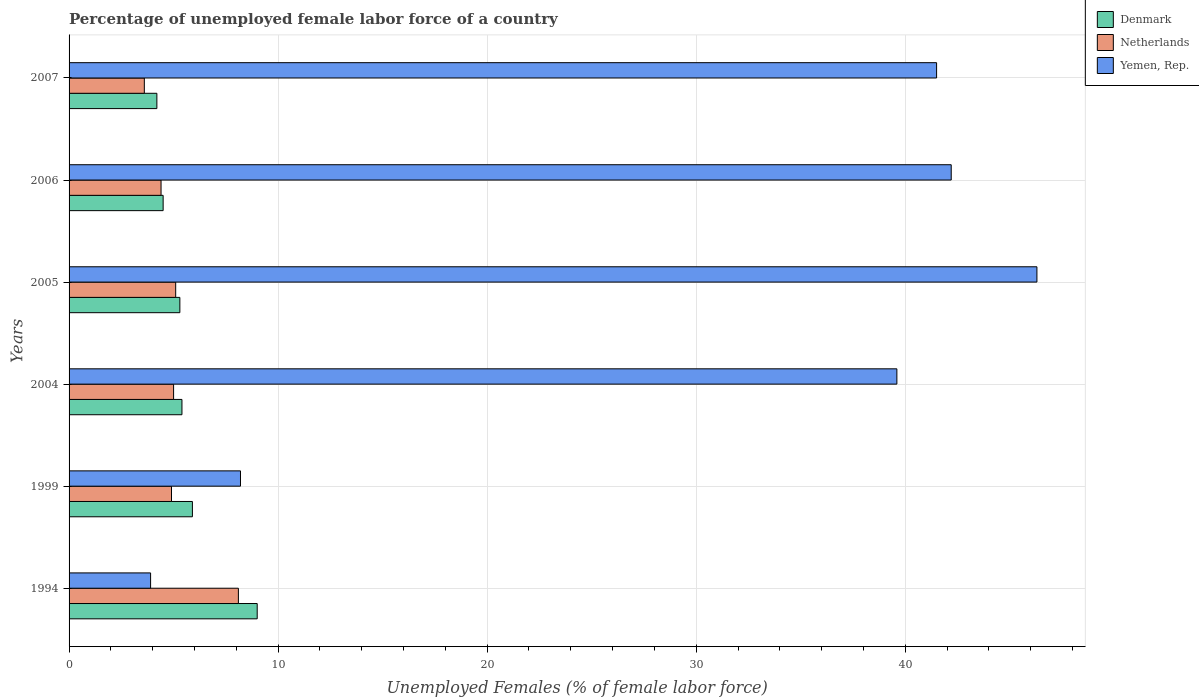Are the number of bars per tick equal to the number of legend labels?
Provide a short and direct response. Yes. Are the number of bars on each tick of the Y-axis equal?
Your answer should be very brief. Yes. How many bars are there on the 1st tick from the top?
Give a very brief answer. 3. What is the label of the 1st group of bars from the top?
Offer a very short reply. 2007. In how many cases, is the number of bars for a given year not equal to the number of legend labels?
Make the answer very short. 0. What is the percentage of unemployed female labor force in Denmark in 2004?
Provide a short and direct response. 5.4. Across all years, what is the maximum percentage of unemployed female labor force in Denmark?
Ensure brevity in your answer.  9. Across all years, what is the minimum percentage of unemployed female labor force in Yemen, Rep.?
Your answer should be very brief. 3.9. What is the total percentage of unemployed female labor force in Netherlands in the graph?
Offer a very short reply. 31.1. What is the difference between the percentage of unemployed female labor force in Denmark in 2005 and that in 2007?
Your answer should be compact. 1.1. What is the difference between the percentage of unemployed female labor force in Yemen, Rep. in 2006 and the percentage of unemployed female labor force in Netherlands in 2007?
Provide a short and direct response. 38.6. What is the average percentage of unemployed female labor force in Yemen, Rep. per year?
Keep it short and to the point. 30.28. In the year 2004, what is the difference between the percentage of unemployed female labor force in Netherlands and percentage of unemployed female labor force in Yemen, Rep.?
Make the answer very short. -34.6. In how many years, is the percentage of unemployed female labor force in Denmark greater than 10 %?
Give a very brief answer. 0. What is the ratio of the percentage of unemployed female labor force in Netherlands in 2004 to that in 2006?
Your answer should be compact. 1.14. Is the percentage of unemployed female labor force in Yemen, Rep. in 1994 less than that in 2004?
Your answer should be compact. Yes. Is the difference between the percentage of unemployed female labor force in Netherlands in 2004 and 2007 greater than the difference between the percentage of unemployed female labor force in Yemen, Rep. in 2004 and 2007?
Your response must be concise. Yes. What is the difference between the highest and the second highest percentage of unemployed female labor force in Netherlands?
Your response must be concise. 3. What is the difference between the highest and the lowest percentage of unemployed female labor force in Denmark?
Offer a terse response. 4.8. Is the sum of the percentage of unemployed female labor force in Yemen, Rep. in 1999 and 2005 greater than the maximum percentage of unemployed female labor force in Denmark across all years?
Ensure brevity in your answer.  Yes. What does the 2nd bar from the top in 2005 represents?
Make the answer very short. Netherlands. What does the 1st bar from the bottom in 2005 represents?
Offer a terse response. Denmark. Is it the case that in every year, the sum of the percentage of unemployed female labor force in Yemen, Rep. and percentage of unemployed female labor force in Netherlands is greater than the percentage of unemployed female labor force in Denmark?
Make the answer very short. Yes. How many bars are there?
Your answer should be compact. 18. How many years are there in the graph?
Ensure brevity in your answer.  6. Does the graph contain any zero values?
Keep it short and to the point. No. How are the legend labels stacked?
Provide a short and direct response. Vertical. What is the title of the graph?
Provide a succinct answer. Percentage of unemployed female labor force of a country. Does "Hong Kong" appear as one of the legend labels in the graph?
Offer a very short reply. No. What is the label or title of the X-axis?
Make the answer very short. Unemployed Females (% of female labor force). What is the Unemployed Females (% of female labor force) of Denmark in 1994?
Your answer should be very brief. 9. What is the Unemployed Females (% of female labor force) in Netherlands in 1994?
Offer a terse response. 8.1. What is the Unemployed Females (% of female labor force) of Yemen, Rep. in 1994?
Ensure brevity in your answer.  3.9. What is the Unemployed Females (% of female labor force) in Denmark in 1999?
Ensure brevity in your answer.  5.9. What is the Unemployed Females (% of female labor force) of Netherlands in 1999?
Your answer should be very brief. 4.9. What is the Unemployed Females (% of female labor force) in Yemen, Rep. in 1999?
Keep it short and to the point. 8.2. What is the Unemployed Females (% of female labor force) of Denmark in 2004?
Provide a short and direct response. 5.4. What is the Unemployed Females (% of female labor force) of Netherlands in 2004?
Keep it short and to the point. 5. What is the Unemployed Females (% of female labor force) of Yemen, Rep. in 2004?
Make the answer very short. 39.6. What is the Unemployed Females (% of female labor force) of Denmark in 2005?
Your answer should be very brief. 5.3. What is the Unemployed Females (% of female labor force) in Netherlands in 2005?
Offer a very short reply. 5.1. What is the Unemployed Females (% of female labor force) of Yemen, Rep. in 2005?
Ensure brevity in your answer.  46.3. What is the Unemployed Females (% of female labor force) of Netherlands in 2006?
Your response must be concise. 4.4. What is the Unemployed Females (% of female labor force) of Yemen, Rep. in 2006?
Offer a very short reply. 42.2. What is the Unemployed Females (% of female labor force) of Denmark in 2007?
Offer a very short reply. 4.2. What is the Unemployed Females (% of female labor force) in Netherlands in 2007?
Provide a short and direct response. 3.6. What is the Unemployed Females (% of female labor force) of Yemen, Rep. in 2007?
Offer a very short reply. 41.5. Across all years, what is the maximum Unemployed Females (% of female labor force) of Denmark?
Give a very brief answer. 9. Across all years, what is the maximum Unemployed Females (% of female labor force) in Netherlands?
Make the answer very short. 8.1. Across all years, what is the maximum Unemployed Females (% of female labor force) of Yemen, Rep.?
Offer a very short reply. 46.3. Across all years, what is the minimum Unemployed Females (% of female labor force) of Denmark?
Give a very brief answer. 4.2. Across all years, what is the minimum Unemployed Females (% of female labor force) in Netherlands?
Your answer should be very brief. 3.6. Across all years, what is the minimum Unemployed Females (% of female labor force) of Yemen, Rep.?
Keep it short and to the point. 3.9. What is the total Unemployed Females (% of female labor force) in Denmark in the graph?
Provide a short and direct response. 34.3. What is the total Unemployed Females (% of female labor force) in Netherlands in the graph?
Keep it short and to the point. 31.1. What is the total Unemployed Females (% of female labor force) of Yemen, Rep. in the graph?
Ensure brevity in your answer.  181.7. What is the difference between the Unemployed Females (% of female labor force) of Netherlands in 1994 and that in 1999?
Provide a succinct answer. 3.2. What is the difference between the Unemployed Females (% of female labor force) in Denmark in 1994 and that in 2004?
Provide a succinct answer. 3.6. What is the difference between the Unemployed Females (% of female labor force) of Netherlands in 1994 and that in 2004?
Give a very brief answer. 3.1. What is the difference between the Unemployed Females (% of female labor force) in Yemen, Rep. in 1994 and that in 2004?
Give a very brief answer. -35.7. What is the difference between the Unemployed Females (% of female labor force) of Yemen, Rep. in 1994 and that in 2005?
Make the answer very short. -42.4. What is the difference between the Unemployed Females (% of female labor force) in Netherlands in 1994 and that in 2006?
Offer a terse response. 3.7. What is the difference between the Unemployed Females (% of female labor force) of Yemen, Rep. in 1994 and that in 2006?
Offer a terse response. -38.3. What is the difference between the Unemployed Females (% of female labor force) in Denmark in 1994 and that in 2007?
Ensure brevity in your answer.  4.8. What is the difference between the Unemployed Females (% of female labor force) in Yemen, Rep. in 1994 and that in 2007?
Your answer should be very brief. -37.6. What is the difference between the Unemployed Females (% of female labor force) in Netherlands in 1999 and that in 2004?
Your answer should be compact. -0.1. What is the difference between the Unemployed Females (% of female labor force) of Yemen, Rep. in 1999 and that in 2004?
Your answer should be compact. -31.4. What is the difference between the Unemployed Females (% of female labor force) in Yemen, Rep. in 1999 and that in 2005?
Your answer should be very brief. -38.1. What is the difference between the Unemployed Females (% of female labor force) of Netherlands in 1999 and that in 2006?
Provide a short and direct response. 0.5. What is the difference between the Unemployed Females (% of female labor force) of Yemen, Rep. in 1999 and that in 2006?
Your answer should be very brief. -34. What is the difference between the Unemployed Females (% of female labor force) of Netherlands in 1999 and that in 2007?
Keep it short and to the point. 1.3. What is the difference between the Unemployed Females (% of female labor force) in Yemen, Rep. in 1999 and that in 2007?
Provide a succinct answer. -33.3. What is the difference between the Unemployed Females (% of female labor force) in Netherlands in 2004 and that in 2005?
Give a very brief answer. -0.1. What is the difference between the Unemployed Females (% of female labor force) in Yemen, Rep. in 2004 and that in 2005?
Your response must be concise. -6.7. What is the difference between the Unemployed Females (% of female labor force) of Denmark in 2004 and that in 2006?
Offer a very short reply. 0.9. What is the difference between the Unemployed Females (% of female labor force) in Netherlands in 2004 and that in 2006?
Offer a terse response. 0.6. What is the difference between the Unemployed Females (% of female labor force) in Yemen, Rep. in 2004 and that in 2006?
Give a very brief answer. -2.6. What is the difference between the Unemployed Females (% of female labor force) of Denmark in 2004 and that in 2007?
Your answer should be very brief. 1.2. What is the difference between the Unemployed Females (% of female labor force) of Yemen, Rep. in 2006 and that in 2007?
Keep it short and to the point. 0.7. What is the difference between the Unemployed Females (% of female labor force) of Denmark in 1994 and the Unemployed Females (% of female labor force) of Yemen, Rep. in 2004?
Offer a terse response. -30.6. What is the difference between the Unemployed Females (% of female labor force) in Netherlands in 1994 and the Unemployed Females (% of female labor force) in Yemen, Rep. in 2004?
Provide a short and direct response. -31.5. What is the difference between the Unemployed Females (% of female labor force) of Denmark in 1994 and the Unemployed Females (% of female labor force) of Yemen, Rep. in 2005?
Provide a succinct answer. -37.3. What is the difference between the Unemployed Females (% of female labor force) in Netherlands in 1994 and the Unemployed Females (% of female labor force) in Yemen, Rep. in 2005?
Your response must be concise. -38.2. What is the difference between the Unemployed Females (% of female labor force) of Denmark in 1994 and the Unemployed Females (% of female labor force) of Netherlands in 2006?
Offer a very short reply. 4.6. What is the difference between the Unemployed Females (% of female labor force) in Denmark in 1994 and the Unemployed Females (% of female labor force) in Yemen, Rep. in 2006?
Provide a short and direct response. -33.2. What is the difference between the Unemployed Females (% of female labor force) of Netherlands in 1994 and the Unemployed Females (% of female labor force) of Yemen, Rep. in 2006?
Give a very brief answer. -34.1. What is the difference between the Unemployed Females (% of female labor force) in Denmark in 1994 and the Unemployed Females (% of female labor force) in Yemen, Rep. in 2007?
Keep it short and to the point. -32.5. What is the difference between the Unemployed Females (% of female labor force) of Netherlands in 1994 and the Unemployed Females (% of female labor force) of Yemen, Rep. in 2007?
Give a very brief answer. -33.4. What is the difference between the Unemployed Females (% of female labor force) of Denmark in 1999 and the Unemployed Females (% of female labor force) of Yemen, Rep. in 2004?
Your answer should be compact. -33.7. What is the difference between the Unemployed Females (% of female labor force) of Netherlands in 1999 and the Unemployed Females (% of female labor force) of Yemen, Rep. in 2004?
Ensure brevity in your answer.  -34.7. What is the difference between the Unemployed Females (% of female labor force) in Denmark in 1999 and the Unemployed Females (% of female labor force) in Yemen, Rep. in 2005?
Your response must be concise. -40.4. What is the difference between the Unemployed Females (% of female labor force) in Netherlands in 1999 and the Unemployed Females (% of female labor force) in Yemen, Rep. in 2005?
Keep it short and to the point. -41.4. What is the difference between the Unemployed Females (% of female labor force) of Denmark in 1999 and the Unemployed Females (% of female labor force) of Netherlands in 2006?
Provide a short and direct response. 1.5. What is the difference between the Unemployed Females (% of female labor force) in Denmark in 1999 and the Unemployed Females (% of female labor force) in Yemen, Rep. in 2006?
Provide a short and direct response. -36.3. What is the difference between the Unemployed Females (% of female labor force) of Netherlands in 1999 and the Unemployed Females (% of female labor force) of Yemen, Rep. in 2006?
Make the answer very short. -37.3. What is the difference between the Unemployed Females (% of female labor force) of Denmark in 1999 and the Unemployed Females (% of female labor force) of Netherlands in 2007?
Your response must be concise. 2.3. What is the difference between the Unemployed Females (% of female labor force) in Denmark in 1999 and the Unemployed Females (% of female labor force) in Yemen, Rep. in 2007?
Ensure brevity in your answer.  -35.6. What is the difference between the Unemployed Females (% of female labor force) in Netherlands in 1999 and the Unemployed Females (% of female labor force) in Yemen, Rep. in 2007?
Provide a succinct answer. -36.6. What is the difference between the Unemployed Females (% of female labor force) of Denmark in 2004 and the Unemployed Females (% of female labor force) of Netherlands in 2005?
Your response must be concise. 0.3. What is the difference between the Unemployed Females (% of female labor force) of Denmark in 2004 and the Unemployed Females (% of female labor force) of Yemen, Rep. in 2005?
Provide a short and direct response. -40.9. What is the difference between the Unemployed Females (% of female labor force) of Netherlands in 2004 and the Unemployed Females (% of female labor force) of Yemen, Rep. in 2005?
Provide a succinct answer. -41.3. What is the difference between the Unemployed Females (% of female labor force) of Denmark in 2004 and the Unemployed Females (% of female labor force) of Yemen, Rep. in 2006?
Provide a succinct answer. -36.8. What is the difference between the Unemployed Females (% of female labor force) in Netherlands in 2004 and the Unemployed Females (% of female labor force) in Yemen, Rep. in 2006?
Make the answer very short. -37.2. What is the difference between the Unemployed Females (% of female labor force) in Denmark in 2004 and the Unemployed Females (% of female labor force) in Netherlands in 2007?
Keep it short and to the point. 1.8. What is the difference between the Unemployed Females (% of female labor force) of Denmark in 2004 and the Unemployed Females (% of female labor force) of Yemen, Rep. in 2007?
Offer a terse response. -36.1. What is the difference between the Unemployed Females (% of female labor force) in Netherlands in 2004 and the Unemployed Females (% of female labor force) in Yemen, Rep. in 2007?
Offer a very short reply. -36.5. What is the difference between the Unemployed Females (% of female labor force) of Denmark in 2005 and the Unemployed Females (% of female labor force) of Netherlands in 2006?
Give a very brief answer. 0.9. What is the difference between the Unemployed Females (% of female labor force) in Denmark in 2005 and the Unemployed Females (% of female labor force) in Yemen, Rep. in 2006?
Your answer should be very brief. -36.9. What is the difference between the Unemployed Females (% of female labor force) of Netherlands in 2005 and the Unemployed Females (% of female labor force) of Yemen, Rep. in 2006?
Your answer should be very brief. -37.1. What is the difference between the Unemployed Females (% of female labor force) of Denmark in 2005 and the Unemployed Females (% of female labor force) of Netherlands in 2007?
Offer a terse response. 1.7. What is the difference between the Unemployed Females (% of female labor force) in Denmark in 2005 and the Unemployed Females (% of female labor force) in Yemen, Rep. in 2007?
Your answer should be compact. -36.2. What is the difference between the Unemployed Females (% of female labor force) in Netherlands in 2005 and the Unemployed Females (% of female labor force) in Yemen, Rep. in 2007?
Offer a very short reply. -36.4. What is the difference between the Unemployed Females (% of female labor force) in Denmark in 2006 and the Unemployed Females (% of female labor force) in Yemen, Rep. in 2007?
Your response must be concise. -37. What is the difference between the Unemployed Females (% of female labor force) of Netherlands in 2006 and the Unemployed Females (% of female labor force) of Yemen, Rep. in 2007?
Give a very brief answer. -37.1. What is the average Unemployed Females (% of female labor force) in Denmark per year?
Provide a short and direct response. 5.72. What is the average Unemployed Females (% of female labor force) in Netherlands per year?
Give a very brief answer. 5.18. What is the average Unemployed Females (% of female labor force) in Yemen, Rep. per year?
Offer a terse response. 30.28. In the year 1994, what is the difference between the Unemployed Females (% of female labor force) of Denmark and Unemployed Females (% of female labor force) of Yemen, Rep.?
Offer a terse response. 5.1. In the year 1999, what is the difference between the Unemployed Females (% of female labor force) in Netherlands and Unemployed Females (% of female labor force) in Yemen, Rep.?
Give a very brief answer. -3.3. In the year 2004, what is the difference between the Unemployed Females (% of female labor force) in Denmark and Unemployed Females (% of female labor force) in Netherlands?
Your answer should be compact. 0.4. In the year 2004, what is the difference between the Unemployed Females (% of female labor force) of Denmark and Unemployed Females (% of female labor force) of Yemen, Rep.?
Give a very brief answer. -34.2. In the year 2004, what is the difference between the Unemployed Females (% of female labor force) in Netherlands and Unemployed Females (% of female labor force) in Yemen, Rep.?
Your answer should be very brief. -34.6. In the year 2005, what is the difference between the Unemployed Females (% of female labor force) of Denmark and Unemployed Females (% of female labor force) of Netherlands?
Make the answer very short. 0.2. In the year 2005, what is the difference between the Unemployed Females (% of female labor force) of Denmark and Unemployed Females (% of female labor force) of Yemen, Rep.?
Offer a very short reply. -41. In the year 2005, what is the difference between the Unemployed Females (% of female labor force) in Netherlands and Unemployed Females (% of female labor force) in Yemen, Rep.?
Offer a terse response. -41.2. In the year 2006, what is the difference between the Unemployed Females (% of female labor force) of Denmark and Unemployed Females (% of female labor force) of Yemen, Rep.?
Offer a terse response. -37.7. In the year 2006, what is the difference between the Unemployed Females (% of female labor force) of Netherlands and Unemployed Females (% of female labor force) of Yemen, Rep.?
Provide a short and direct response. -37.8. In the year 2007, what is the difference between the Unemployed Females (% of female labor force) of Denmark and Unemployed Females (% of female labor force) of Netherlands?
Ensure brevity in your answer.  0.6. In the year 2007, what is the difference between the Unemployed Females (% of female labor force) in Denmark and Unemployed Females (% of female labor force) in Yemen, Rep.?
Provide a succinct answer. -37.3. In the year 2007, what is the difference between the Unemployed Females (% of female labor force) in Netherlands and Unemployed Females (% of female labor force) in Yemen, Rep.?
Ensure brevity in your answer.  -37.9. What is the ratio of the Unemployed Females (% of female labor force) in Denmark in 1994 to that in 1999?
Offer a terse response. 1.53. What is the ratio of the Unemployed Females (% of female labor force) of Netherlands in 1994 to that in 1999?
Your response must be concise. 1.65. What is the ratio of the Unemployed Females (% of female labor force) of Yemen, Rep. in 1994 to that in 1999?
Give a very brief answer. 0.48. What is the ratio of the Unemployed Females (% of female labor force) of Netherlands in 1994 to that in 2004?
Your answer should be very brief. 1.62. What is the ratio of the Unemployed Females (% of female labor force) of Yemen, Rep. in 1994 to that in 2004?
Ensure brevity in your answer.  0.1. What is the ratio of the Unemployed Females (% of female labor force) of Denmark in 1994 to that in 2005?
Keep it short and to the point. 1.7. What is the ratio of the Unemployed Females (% of female labor force) of Netherlands in 1994 to that in 2005?
Your response must be concise. 1.59. What is the ratio of the Unemployed Females (% of female labor force) of Yemen, Rep. in 1994 to that in 2005?
Offer a very short reply. 0.08. What is the ratio of the Unemployed Females (% of female labor force) of Netherlands in 1994 to that in 2006?
Your answer should be compact. 1.84. What is the ratio of the Unemployed Females (% of female labor force) of Yemen, Rep. in 1994 to that in 2006?
Provide a short and direct response. 0.09. What is the ratio of the Unemployed Females (% of female labor force) of Denmark in 1994 to that in 2007?
Keep it short and to the point. 2.14. What is the ratio of the Unemployed Females (% of female labor force) in Netherlands in 1994 to that in 2007?
Give a very brief answer. 2.25. What is the ratio of the Unemployed Females (% of female labor force) in Yemen, Rep. in 1994 to that in 2007?
Your answer should be very brief. 0.09. What is the ratio of the Unemployed Females (% of female labor force) in Denmark in 1999 to that in 2004?
Provide a short and direct response. 1.09. What is the ratio of the Unemployed Females (% of female labor force) in Netherlands in 1999 to that in 2004?
Provide a short and direct response. 0.98. What is the ratio of the Unemployed Females (% of female labor force) of Yemen, Rep. in 1999 to that in 2004?
Provide a succinct answer. 0.21. What is the ratio of the Unemployed Females (% of female labor force) of Denmark in 1999 to that in 2005?
Give a very brief answer. 1.11. What is the ratio of the Unemployed Females (% of female labor force) in Netherlands in 1999 to that in 2005?
Offer a terse response. 0.96. What is the ratio of the Unemployed Females (% of female labor force) in Yemen, Rep. in 1999 to that in 2005?
Make the answer very short. 0.18. What is the ratio of the Unemployed Females (% of female labor force) in Denmark in 1999 to that in 2006?
Your response must be concise. 1.31. What is the ratio of the Unemployed Females (% of female labor force) in Netherlands in 1999 to that in 2006?
Provide a short and direct response. 1.11. What is the ratio of the Unemployed Females (% of female labor force) of Yemen, Rep. in 1999 to that in 2006?
Keep it short and to the point. 0.19. What is the ratio of the Unemployed Females (% of female labor force) of Denmark in 1999 to that in 2007?
Keep it short and to the point. 1.4. What is the ratio of the Unemployed Females (% of female labor force) of Netherlands in 1999 to that in 2007?
Offer a very short reply. 1.36. What is the ratio of the Unemployed Females (% of female labor force) in Yemen, Rep. in 1999 to that in 2007?
Offer a very short reply. 0.2. What is the ratio of the Unemployed Females (% of female labor force) in Denmark in 2004 to that in 2005?
Ensure brevity in your answer.  1.02. What is the ratio of the Unemployed Females (% of female labor force) in Netherlands in 2004 to that in 2005?
Ensure brevity in your answer.  0.98. What is the ratio of the Unemployed Females (% of female labor force) of Yemen, Rep. in 2004 to that in 2005?
Offer a terse response. 0.86. What is the ratio of the Unemployed Females (% of female labor force) in Netherlands in 2004 to that in 2006?
Your answer should be very brief. 1.14. What is the ratio of the Unemployed Females (% of female labor force) in Yemen, Rep. in 2004 to that in 2006?
Your answer should be very brief. 0.94. What is the ratio of the Unemployed Females (% of female labor force) of Netherlands in 2004 to that in 2007?
Offer a very short reply. 1.39. What is the ratio of the Unemployed Females (% of female labor force) in Yemen, Rep. in 2004 to that in 2007?
Your answer should be very brief. 0.95. What is the ratio of the Unemployed Females (% of female labor force) in Denmark in 2005 to that in 2006?
Give a very brief answer. 1.18. What is the ratio of the Unemployed Females (% of female labor force) in Netherlands in 2005 to that in 2006?
Offer a terse response. 1.16. What is the ratio of the Unemployed Females (% of female labor force) in Yemen, Rep. in 2005 to that in 2006?
Keep it short and to the point. 1.1. What is the ratio of the Unemployed Females (% of female labor force) in Denmark in 2005 to that in 2007?
Provide a succinct answer. 1.26. What is the ratio of the Unemployed Females (% of female labor force) in Netherlands in 2005 to that in 2007?
Your response must be concise. 1.42. What is the ratio of the Unemployed Females (% of female labor force) in Yemen, Rep. in 2005 to that in 2007?
Make the answer very short. 1.12. What is the ratio of the Unemployed Females (% of female labor force) of Denmark in 2006 to that in 2007?
Your response must be concise. 1.07. What is the ratio of the Unemployed Females (% of female labor force) of Netherlands in 2006 to that in 2007?
Your answer should be very brief. 1.22. What is the ratio of the Unemployed Females (% of female labor force) of Yemen, Rep. in 2006 to that in 2007?
Give a very brief answer. 1.02. What is the difference between the highest and the second highest Unemployed Females (% of female labor force) in Denmark?
Give a very brief answer. 3.1. What is the difference between the highest and the second highest Unemployed Females (% of female labor force) in Netherlands?
Keep it short and to the point. 3. What is the difference between the highest and the second highest Unemployed Females (% of female labor force) of Yemen, Rep.?
Make the answer very short. 4.1. What is the difference between the highest and the lowest Unemployed Females (% of female labor force) in Denmark?
Offer a very short reply. 4.8. What is the difference between the highest and the lowest Unemployed Females (% of female labor force) in Netherlands?
Provide a short and direct response. 4.5. What is the difference between the highest and the lowest Unemployed Females (% of female labor force) of Yemen, Rep.?
Your answer should be very brief. 42.4. 